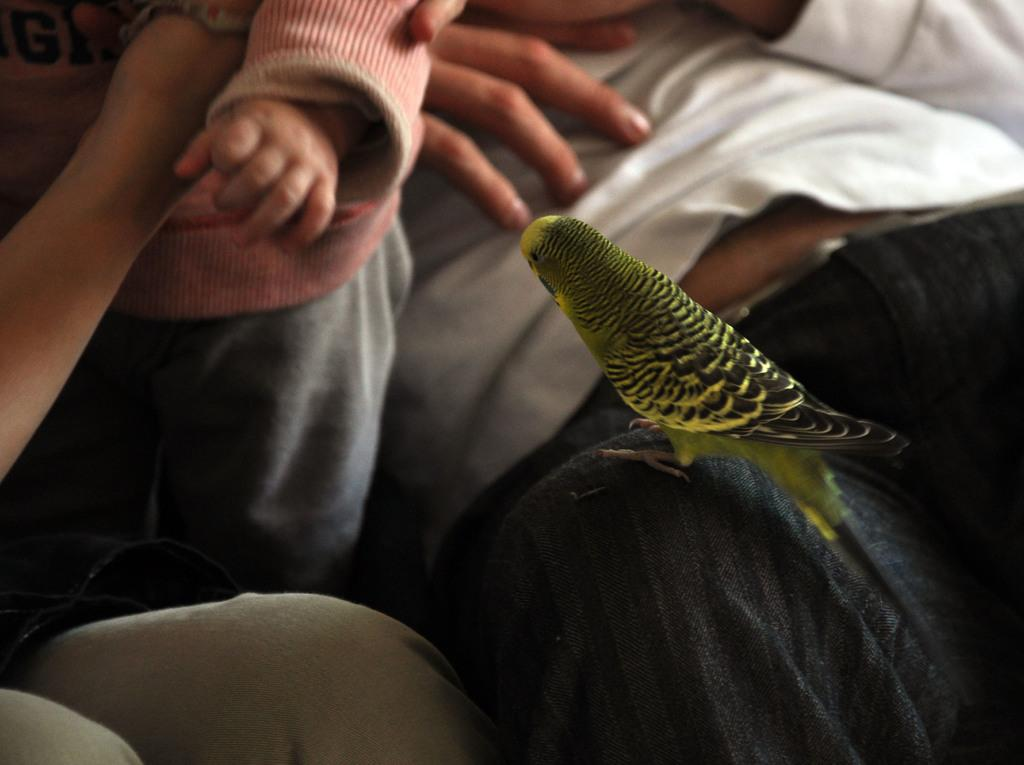What is: What is the condition of the people in the image? The people in the image are partially covered. Can you describe any other elements in the image? Yes, a bird is present on a person in the image. What type of bread is being used to cover the people in the image? There is no bread present in the image; the people are partially covered by clothing or other materials. 